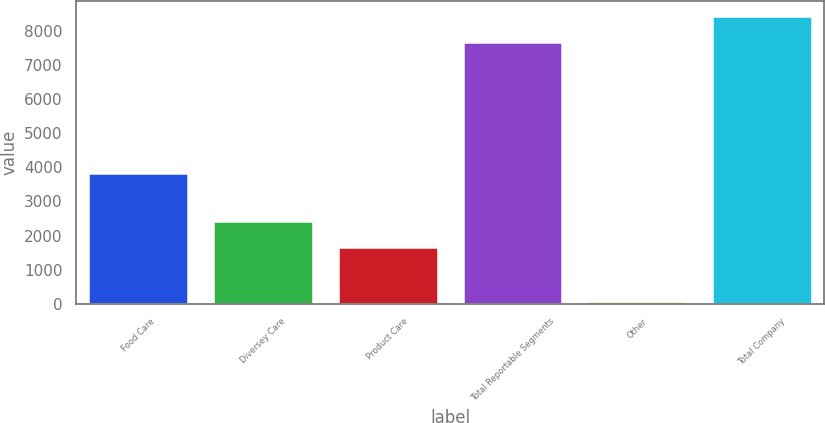Convert chart to OTSL. <chart><loc_0><loc_0><loc_500><loc_500><bar_chart><fcel>Food Care<fcel>Diversey Care<fcel>Product Care<fcel>Total Reportable Segments<fcel>Other<fcel>Total Company<nl><fcel>3835.3<fcel>2421.34<fcel>1655<fcel>7663.4<fcel>87.1<fcel>8429.74<nl></chart> 